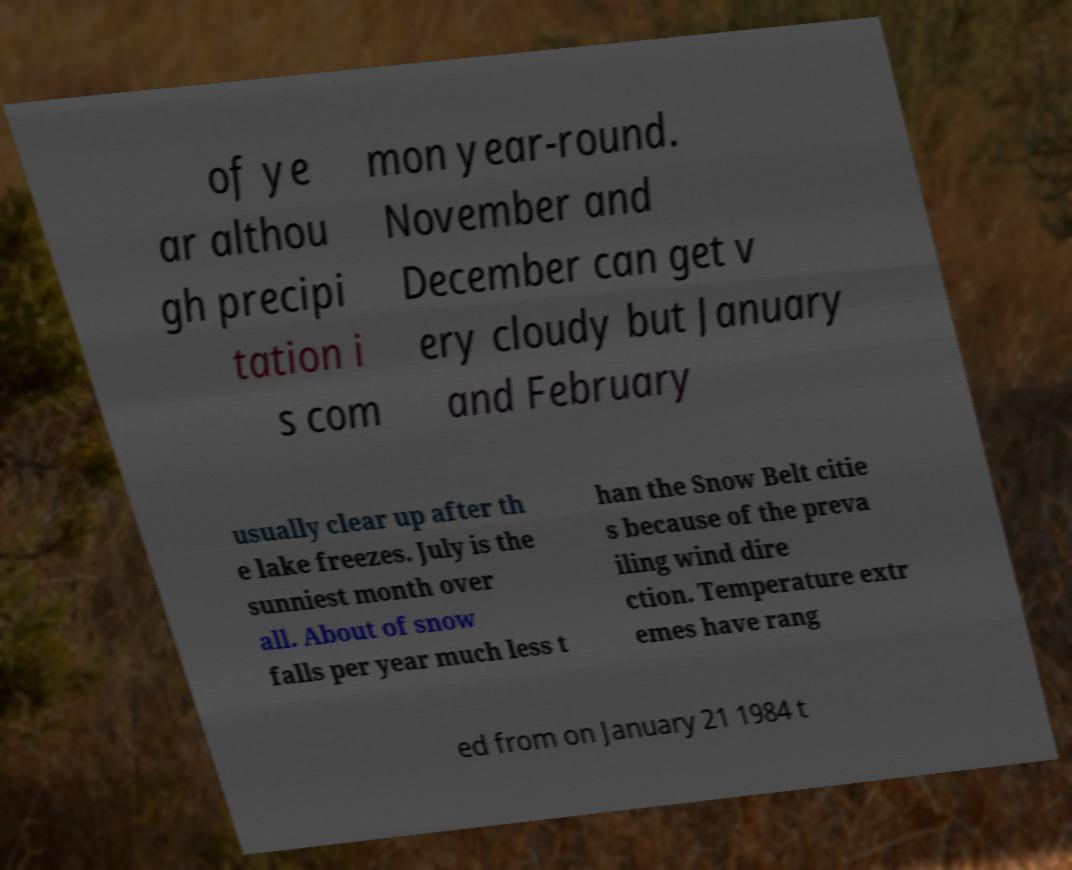Please read and relay the text visible in this image. What does it say? of ye ar althou gh precipi tation i s com mon year-round. November and December can get v ery cloudy but January and February usually clear up after th e lake freezes. July is the sunniest month over all. About of snow falls per year much less t han the Snow Belt citie s because of the preva iling wind dire ction. Temperature extr emes have rang ed from on January 21 1984 t 